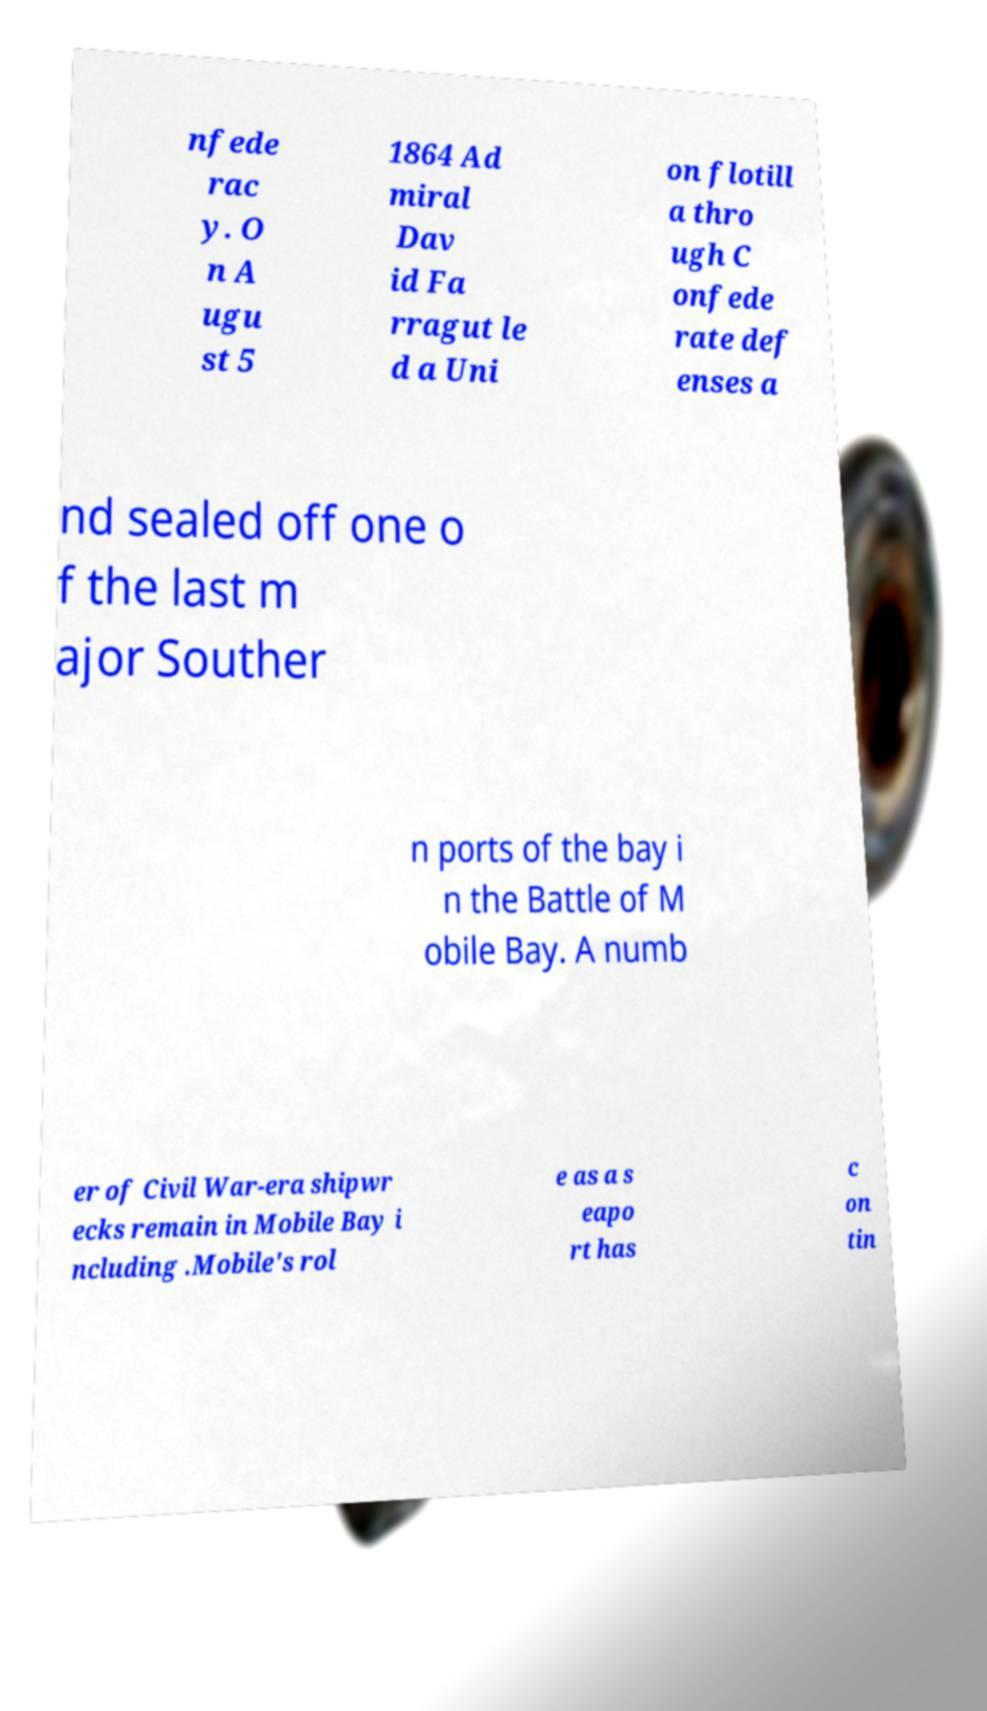There's text embedded in this image that I need extracted. Can you transcribe it verbatim? nfede rac y. O n A ugu st 5 1864 Ad miral Dav id Fa rragut le d a Uni on flotill a thro ugh C onfede rate def enses a nd sealed off one o f the last m ajor Souther n ports of the bay i n the Battle of M obile Bay. A numb er of Civil War-era shipwr ecks remain in Mobile Bay i ncluding .Mobile's rol e as a s eapo rt has c on tin 